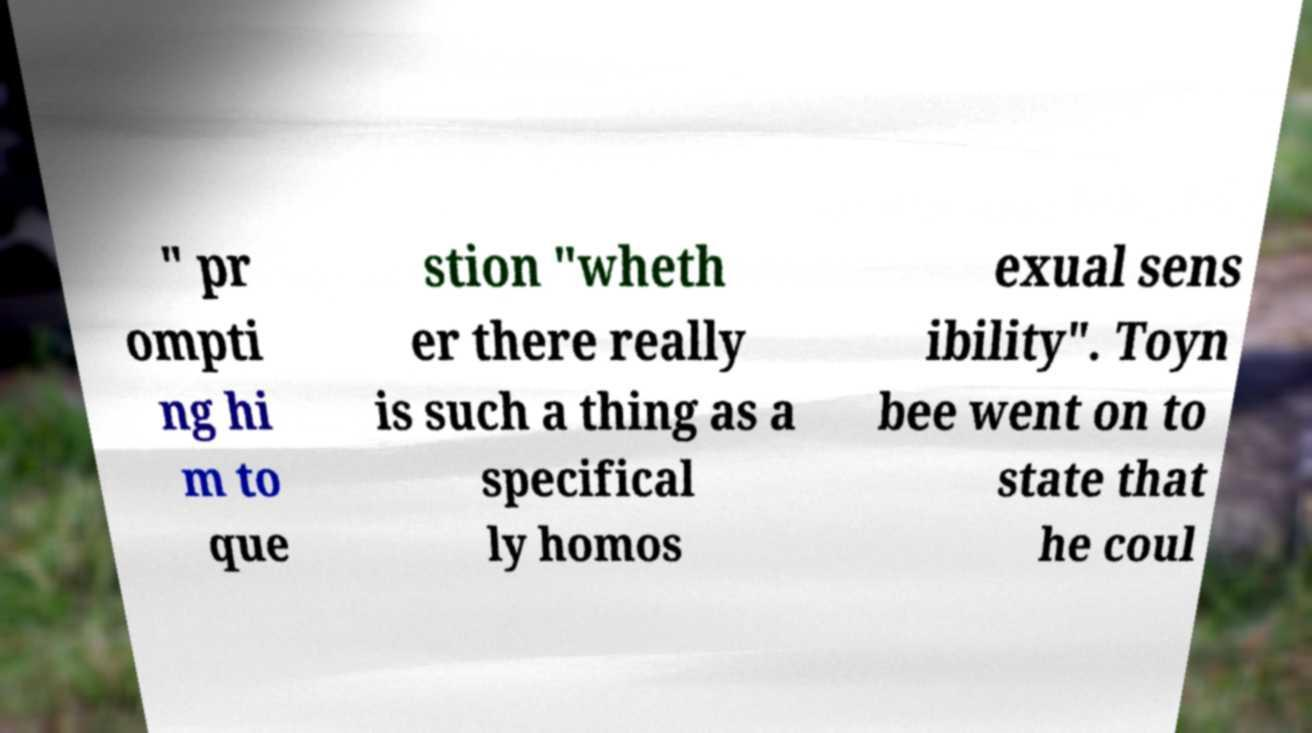Can you read and provide the text displayed in the image?This photo seems to have some interesting text. Can you extract and type it out for me? " pr ompti ng hi m to que stion "wheth er there really is such a thing as a specifical ly homos exual sens ibility". Toyn bee went on to state that he coul 